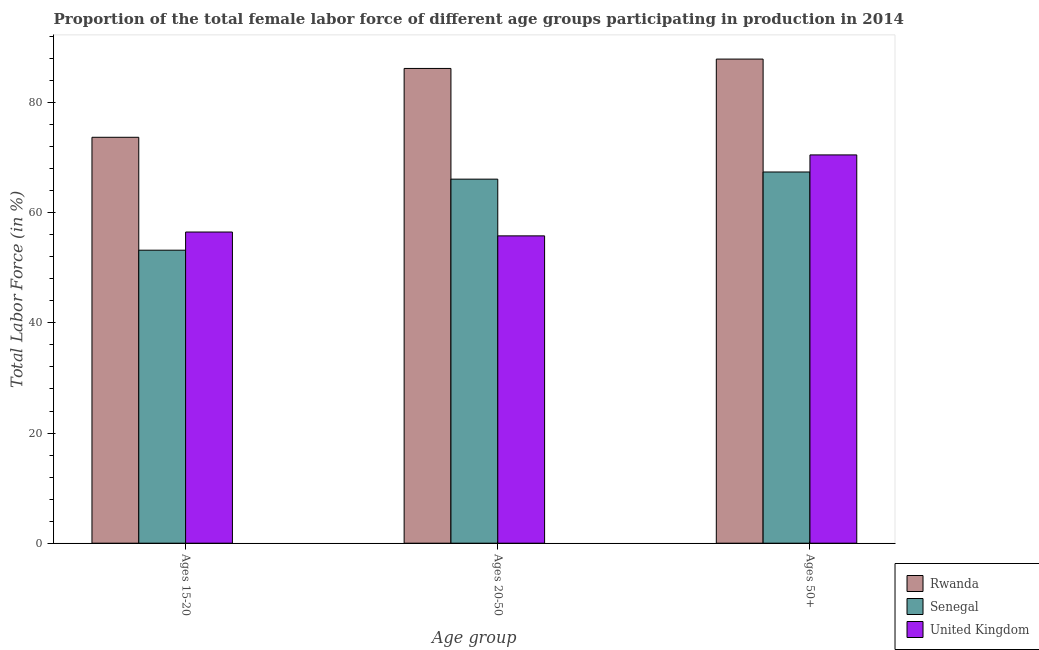Are the number of bars per tick equal to the number of legend labels?
Offer a terse response. Yes. What is the label of the 2nd group of bars from the left?
Your answer should be compact. Ages 20-50. What is the percentage of female labor force above age 50 in United Kingdom?
Your answer should be very brief. 70.5. Across all countries, what is the maximum percentage of female labor force above age 50?
Make the answer very short. 87.9. Across all countries, what is the minimum percentage of female labor force within the age group 20-50?
Your response must be concise. 55.8. In which country was the percentage of female labor force above age 50 maximum?
Provide a succinct answer. Rwanda. In which country was the percentage of female labor force above age 50 minimum?
Provide a succinct answer. Senegal. What is the total percentage of female labor force above age 50 in the graph?
Offer a very short reply. 225.8. What is the difference between the percentage of female labor force within the age group 20-50 in Rwanda and that in Senegal?
Provide a short and direct response. 20.1. What is the difference between the percentage of female labor force above age 50 in Senegal and the percentage of female labor force within the age group 20-50 in Rwanda?
Offer a very short reply. -18.8. What is the average percentage of female labor force within the age group 20-50 per country?
Ensure brevity in your answer.  69.37. In how many countries, is the percentage of female labor force within the age group 15-20 greater than 24 %?
Your response must be concise. 3. What is the ratio of the percentage of female labor force above age 50 in Rwanda to that in Senegal?
Give a very brief answer. 1.3. Is the difference between the percentage of female labor force within the age group 20-50 in United Kingdom and Senegal greater than the difference between the percentage of female labor force above age 50 in United Kingdom and Senegal?
Your answer should be compact. No. What is the difference between the highest and the second highest percentage of female labor force above age 50?
Provide a short and direct response. 17.4. What is the difference between the highest and the lowest percentage of female labor force above age 50?
Provide a short and direct response. 20.5. In how many countries, is the percentage of female labor force within the age group 15-20 greater than the average percentage of female labor force within the age group 15-20 taken over all countries?
Offer a very short reply. 1. What does the 3rd bar from the right in Ages 20-50 represents?
Ensure brevity in your answer.  Rwanda. Are all the bars in the graph horizontal?
Offer a terse response. No. What is the difference between two consecutive major ticks on the Y-axis?
Your answer should be compact. 20. Does the graph contain any zero values?
Make the answer very short. No. Does the graph contain grids?
Give a very brief answer. No. Where does the legend appear in the graph?
Provide a succinct answer. Bottom right. How many legend labels are there?
Offer a terse response. 3. What is the title of the graph?
Make the answer very short. Proportion of the total female labor force of different age groups participating in production in 2014. Does "European Union" appear as one of the legend labels in the graph?
Provide a short and direct response. No. What is the label or title of the X-axis?
Your answer should be compact. Age group. What is the label or title of the Y-axis?
Your answer should be very brief. Total Labor Force (in %). What is the Total Labor Force (in %) of Rwanda in Ages 15-20?
Give a very brief answer. 73.7. What is the Total Labor Force (in %) of Senegal in Ages 15-20?
Your answer should be very brief. 53.2. What is the Total Labor Force (in %) in United Kingdom in Ages 15-20?
Offer a very short reply. 56.5. What is the Total Labor Force (in %) in Rwanda in Ages 20-50?
Your response must be concise. 86.2. What is the Total Labor Force (in %) in Senegal in Ages 20-50?
Offer a very short reply. 66.1. What is the Total Labor Force (in %) in United Kingdom in Ages 20-50?
Your response must be concise. 55.8. What is the Total Labor Force (in %) in Rwanda in Ages 50+?
Ensure brevity in your answer.  87.9. What is the Total Labor Force (in %) in Senegal in Ages 50+?
Offer a very short reply. 67.4. What is the Total Labor Force (in %) of United Kingdom in Ages 50+?
Keep it short and to the point. 70.5. Across all Age group, what is the maximum Total Labor Force (in %) in Rwanda?
Give a very brief answer. 87.9. Across all Age group, what is the maximum Total Labor Force (in %) in Senegal?
Ensure brevity in your answer.  67.4. Across all Age group, what is the maximum Total Labor Force (in %) in United Kingdom?
Ensure brevity in your answer.  70.5. Across all Age group, what is the minimum Total Labor Force (in %) in Rwanda?
Make the answer very short. 73.7. Across all Age group, what is the minimum Total Labor Force (in %) in Senegal?
Make the answer very short. 53.2. Across all Age group, what is the minimum Total Labor Force (in %) in United Kingdom?
Provide a short and direct response. 55.8. What is the total Total Labor Force (in %) in Rwanda in the graph?
Make the answer very short. 247.8. What is the total Total Labor Force (in %) of Senegal in the graph?
Your response must be concise. 186.7. What is the total Total Labor Force (in %) in United Kingdom in the graph?
Offer a terse response. 182.8. What is the difference between the Total Labor Force (in %) in Senegal in Ages 15-20 and that in Ages 20-50?
Make the answer very short. -12.9. What is the difference between the Total Labor Force (in %) in Senegal in Ages 15-20 and that in Ages 50+?
Ensure brevity in your answer.  -14.2. What is the difference between the Total Labor Force (in %) in United Kingdom in Ages 15-20 and that in Ages 50+?
Your answer should be compact. -14. What is the difference between the Total Labor Force (in %) of Senegal in Ages 20-50 and that in Ages 50+?
Your answer should be very brief. -1.3. What is the difference between the Total Labor Force (in %) of United Kingdom in Ages 20-50 and that in Ages 50+?
Ensure brevity in your answer.  -14.7. What is the difference between the Total Labor Force (in %) of Rwanda in Ages 15-20 and the Total Labor Force (in %) of United Kingdom in Ages 20-50?
Keep it short and to the point. 17.9. What is the difference between the Total Labor Force (in %) in Rwanda in Ages 15-20 and the Total Labor Force (in %) in Senegal in Ages 50+?
Provide a succinct answer. 6.3. What is the difference between the Total Labor Force (in %) in Senegal in Ages 15-20 and the Total Labor Force (in %) in United Kingdom in Ages 50+?
Provide a short and direct response. -17.3. What is the difference between the Total Labor Force (in %) in Rwanda in Ages 20-50 and the Total Labor Force (in %) in Senegal in Ages 50+?
Give a very brief answer. 18.8. What is the difference between the Total Labor Force (in %) of Rwanda in Ages 20-50 and the Total Labor Force (in %) of United Kingdom in Ages 50+?
Keep it short and to the point. 15.7. What is the average Total Labor Force (in %) in Rwanda per Age group?
Provide a succinct answer. 82.6. What is the average Total Labor Force (in %) of Senegal per Age group?
Provide a succinct answer. 62.23. What is the average Total Labor Force (in %) of United Kingdom per Age group?
Your answer should be very brief. 60.93. What is the difference between the Total Labor Force (in %) of Rwanda and Total Labor Force (in %) of Senegal in Ages 15-20?
Make the answer very short. 20.5. What is the difference between the Total Labor Force (in %) of Senegal and Total Labor Force (in %) of United Kingdom in Ages 15-20?
Ensure brevity in your answer.  -3.3. What is the difference between the Total Labor Force (in %) of Rwanda and Total Labor Force (in %) of Senegal in Ages 20-50?
Provide a succinct answer. 20.1. What is the difference between the Total Labor Force (in %) of Rwanda and Total Labor Force (in %) of United Kingdom in Ages 20-50?
Offer a very short reply. 30.4. What is the difference between the Total Labor Force (in %) of Rwanda and Total Labor Force (in %) of United Kingdom in Ages 50+?
Keep it short and to the point. 17.4. What is the difference between the Total Labor Force (in %) of Senegal and Total Labor Force (in %) of United Kingdom in Ages 50+?
Make the answer very short. -3.1. What is the ratio of the Total Labor Force (in %) of Rwanda in Ages 15-20 to that in Ages 20-50?
Keep it short and to the point. 0.85. What is the ratio of the Total Labor Force (in %) of Senegal in Ages 15-20 to that in Ages 20-50?
Your response must be concise. 0.8. What is the ratio of the Total Labor Force (in %) in United Kingdom in Ages 15-20 to that in Ages 20-50?
Ensure brevity in your answer.  1.01. What is the ratio of the Total Labor Force (in %) of Rwanda in Ages 15-20 to that in Ages 50+?
Your answer should be compact. 0.84. What is the ratio of the Total Labor Force (in %) in Senegal in Ages 15-20 to that in Ages 50+?
Make the answer very short. 0.79. What is the ratio of the Total Labor Force (in %) in United Kingdom in Ages 15-20 to that in Ages 50+?
Give a very brief answer. 0.8. What is the ratio of the Total Labor Force (in %) of Rwanda in Ages 20-50 to that in Ages 50+?
Your answer should be very brief. 0.98. What is the ratio of the Total Labor Force (in %) of Senegal in Ages 20-50 to that in Ages 50+?
Provide a short and direct response. 0.98. What is the ratio of the Total Labor Force (in %) in United Kingdom in Ages 20-50 to that in Ages 50+?
Give a very brief answer. 0.79. What is the difference between the highest and the second highest Total Labor Force (in %) in United Kingdom?
Keep it short and to the point. 14. What is the difference between the highest and the lowest Total Labor Force (in %) of Rwanda?
Provide a succinct answer. 14.2. What is the difference between the highest and the lowest Total Labor Force (in %) of United Kingdom?
Give a very brief answer. 14.7. 